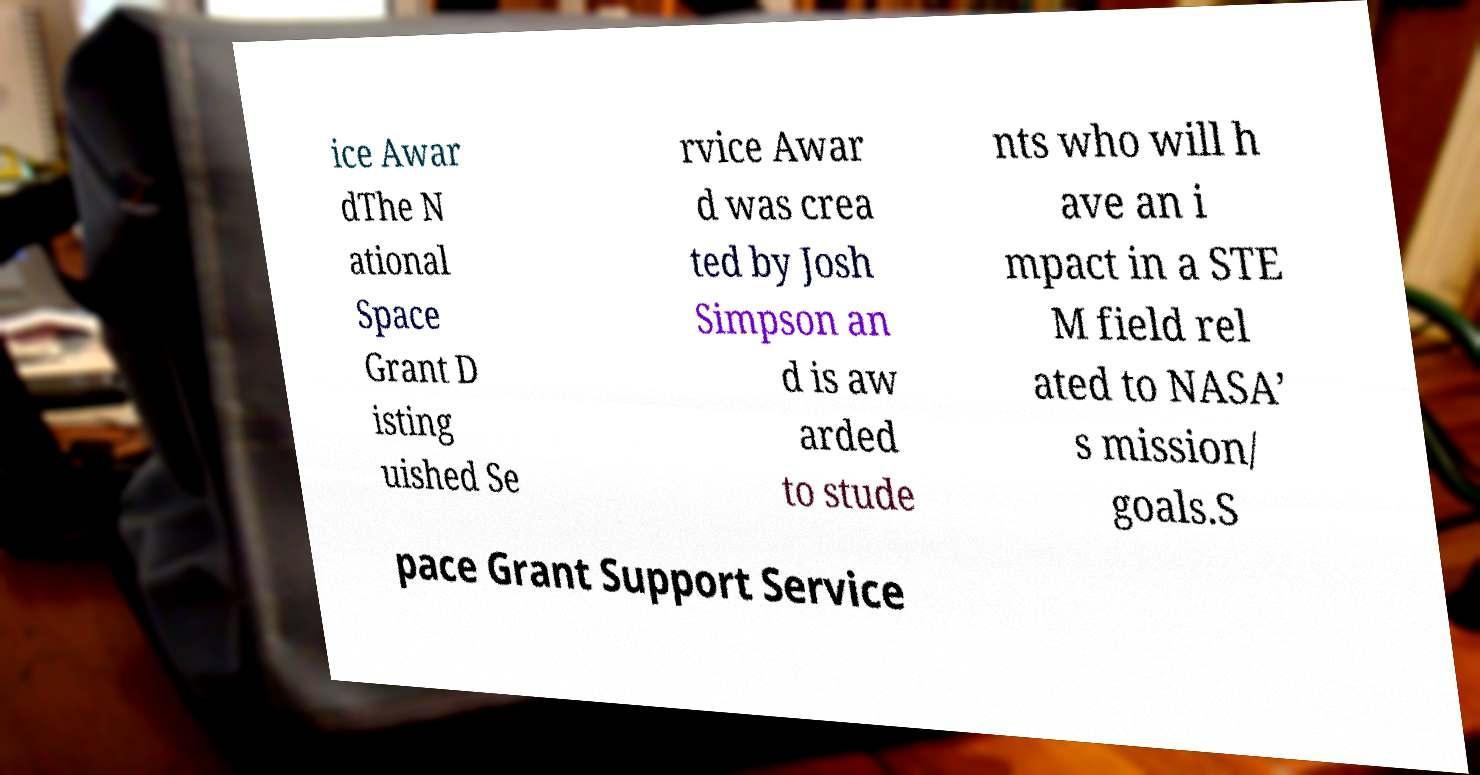Could you extract and type out the text from this image? ice Awar dThe N ational Space Grant D isting uished Se rvice Awar d was crea ted by Josh Simpson an d is aw arded to stude nts who will h ave an i mpact in a STE M field rel ated to NASA’ s mission/ goals.S pace Grant Support Service 